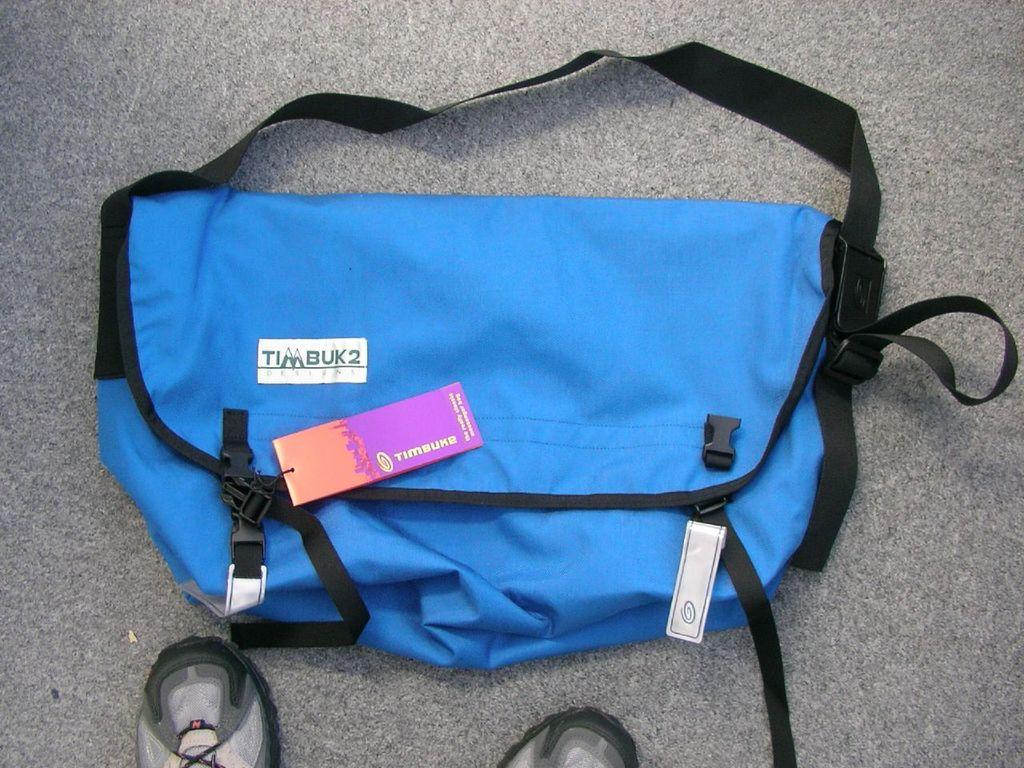What is on the bag in the image? There is a tag on the bag in the image. What is the surface that the bag is placed on? The bag is placed on an ash-colored surface. What else can be seen at the bottom of the image? There are footwear at the bottom of the image. Is there a lock on the bag in the image? There is no mention of a lock on the bag in the provided facts, so we cannot determine if there is one or not. However, based on the facts given, there is no direct indication of a lock on the bag. 